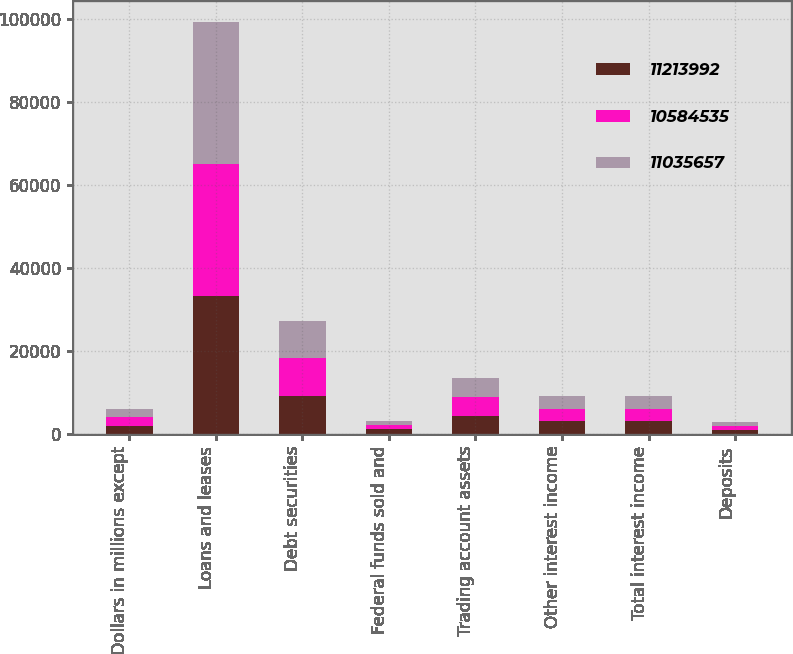<chart> <loc_0><loc_0><loc_500><loc_500><stacked_bar_chart><ecel><fcel>(Dollars in millions except<fcel>Loans and leases<fcel>Debt securities<fcel>Federal funds sold and<fcel>Trading account assets<fcel>Other interest income<fcel>Total interest income<fcel>Deposits<nl><fcel>1.1214e+07<fcel>2016<fcel>33228<fcel>9167<fcel>1118<fcel>4423<fcel>3121<fcel>3026<fcel>1015<nl><fcel>1.05845e+07<fcel>2015<fcel>31918<fcel>9178<fcel>988<fcel>4397<fcel>3026<fcel>3026<fcel>861<nl><fcel>1.10357e+07<fcel>2014<fcel>34145<fcel>9010<fcel>1039<fcel>4561<fcel>2959<fcel>3026<fcel>1080<nl></chart> 